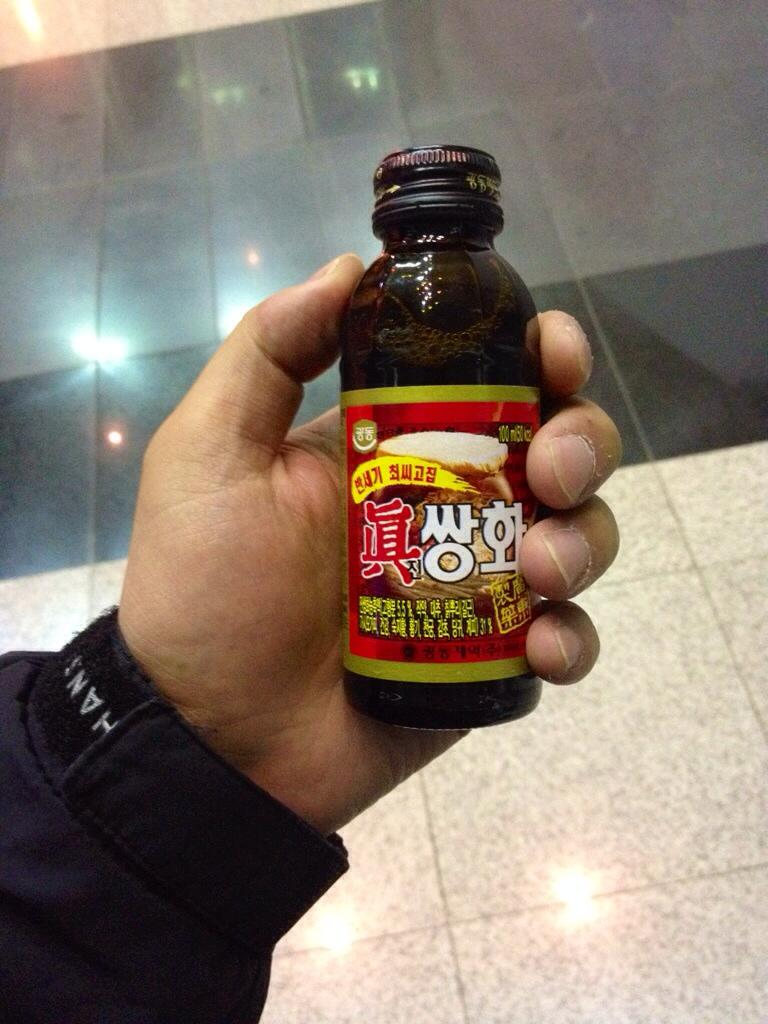Who is present in the image? There is a man in the image. What is the man holding in his hand? The man is holding a tonic bottle in his hand. What type of cough medicine is on the table in the image? There is no table or cough medicine present in the image; it only features a man holding a tonic bottle. 